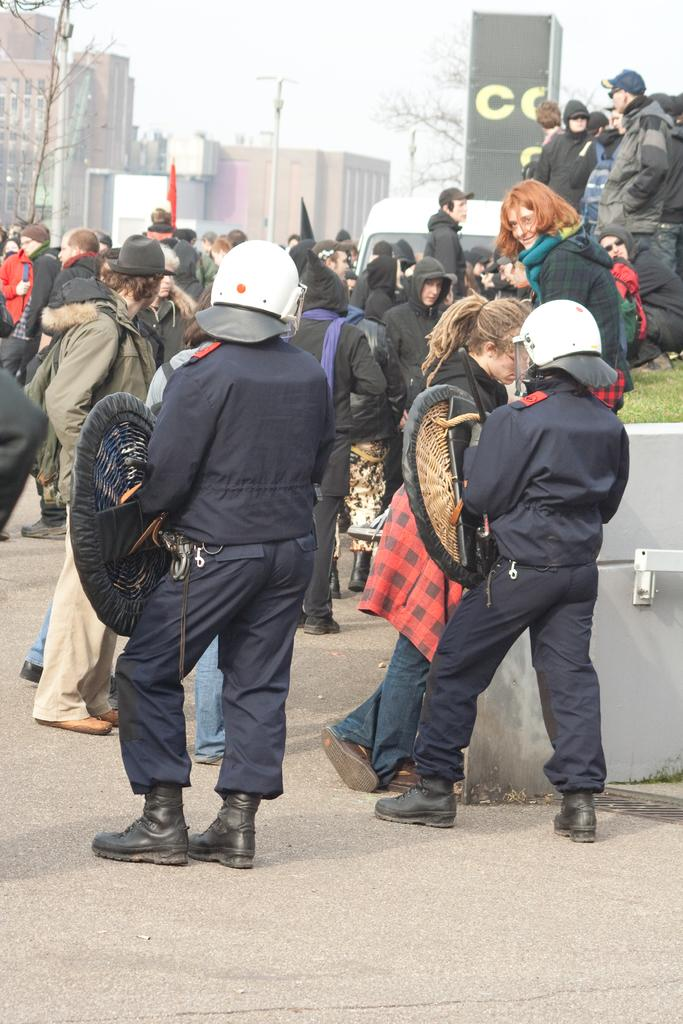What is happening on the road in the image? There are many people walking on the road in the image. Can you identify any specific individuals in the image? Two persons in the front appear to be police. What can be seen at the bottom of the image? There is ground visible at the bottom of the image. What is visible in the background of the image? There are buildings in the background of the image. How many apples can be seen floating in the river in the image? There are no apples or rivers present in the image; it features people walking on a road with buildings in the background. What type of duck is swimming in the pond near the police officers? There is no duck or pond present in the image; it only shows people walking on the road and buildings in the background. 